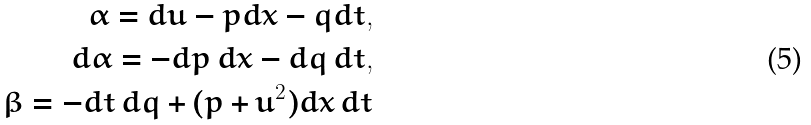Convert formula to latex. <formula><loc_0><loc_0><loc_500><loc_500>\alpha = d u - p d x - q d t , \\ d \alpha = - d p \, d x - d q \, d t , \\ \beta = - d t \, d q + ( p + u ^ { 2 } ) d x \, d t</formula> 